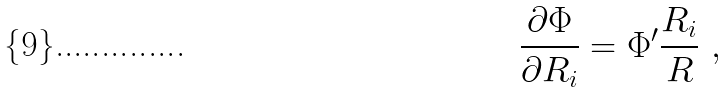Convert formula to latex. <formula><loc_0><loc_0><loc_500><loc_500>\frac { \partial \Phi } { \partial R _ { i } } = \Phi ^ { \prime } \frac { R _ { i } } { R } \ ,</formula> 